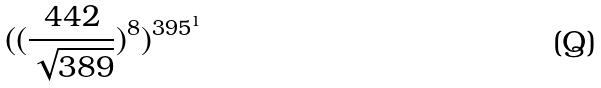Convert formula to latex. <formula><loc_0><loc_0><loc_500><loc_500>( ( \frac { 4 4 2 } { \sqrt { 3 8 9 } } ) ^ { 8 } ) ^ { 3 9 5 ^ { 1 } }</formula> 